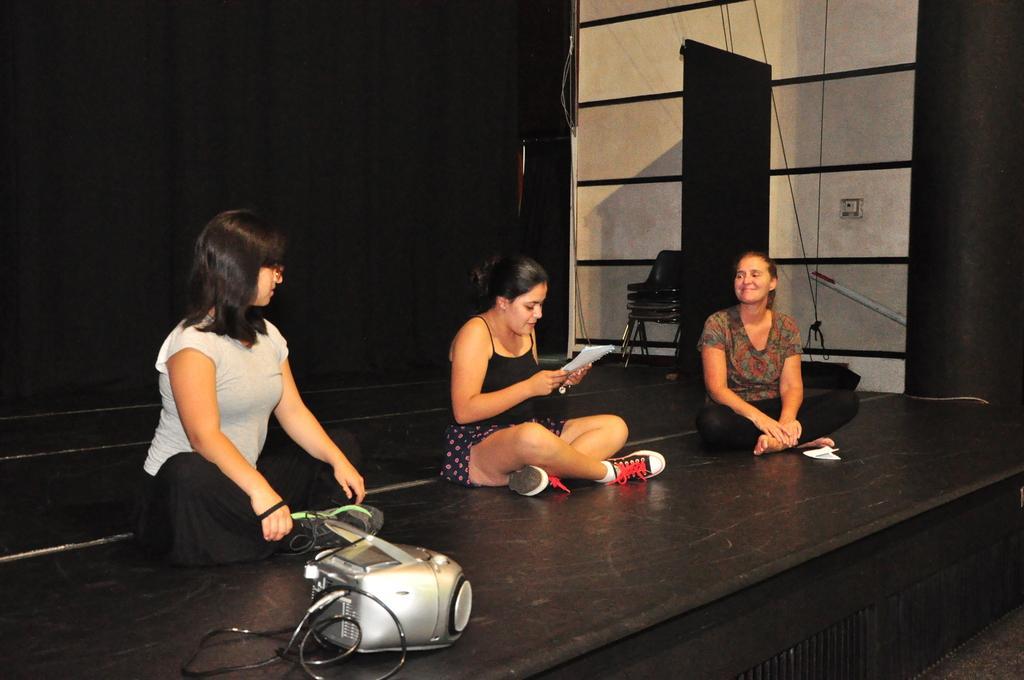Can you describe this image briefly? In this image we can see women sitting on the dais. At the bottom of the image we can see a projector. In the background there is a wall, switch board and curtains. 